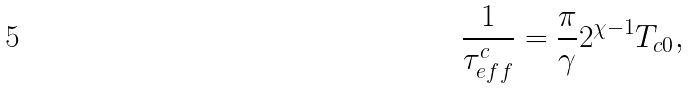Convert formula to latex. <formula><loc_0><loc_0><loc_500><loc_500>\frac { 1 } { \tau _ { e f f } ^ { c } } = \frac { \pi } { \gamma } 2 ^ { \chi - 1 } T _ { c 0 } ,</formula> 